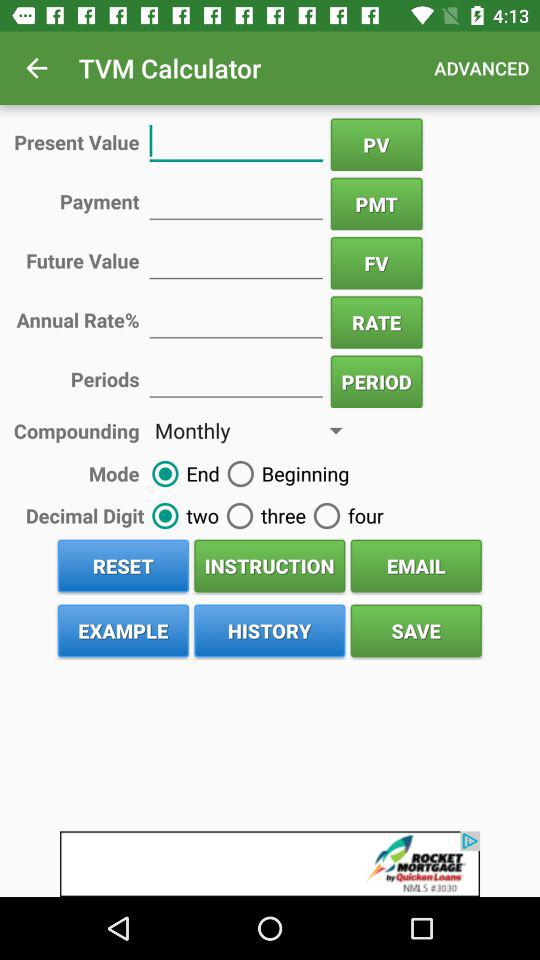What is the name of the application? The name of the application is "TVM Calculator". 